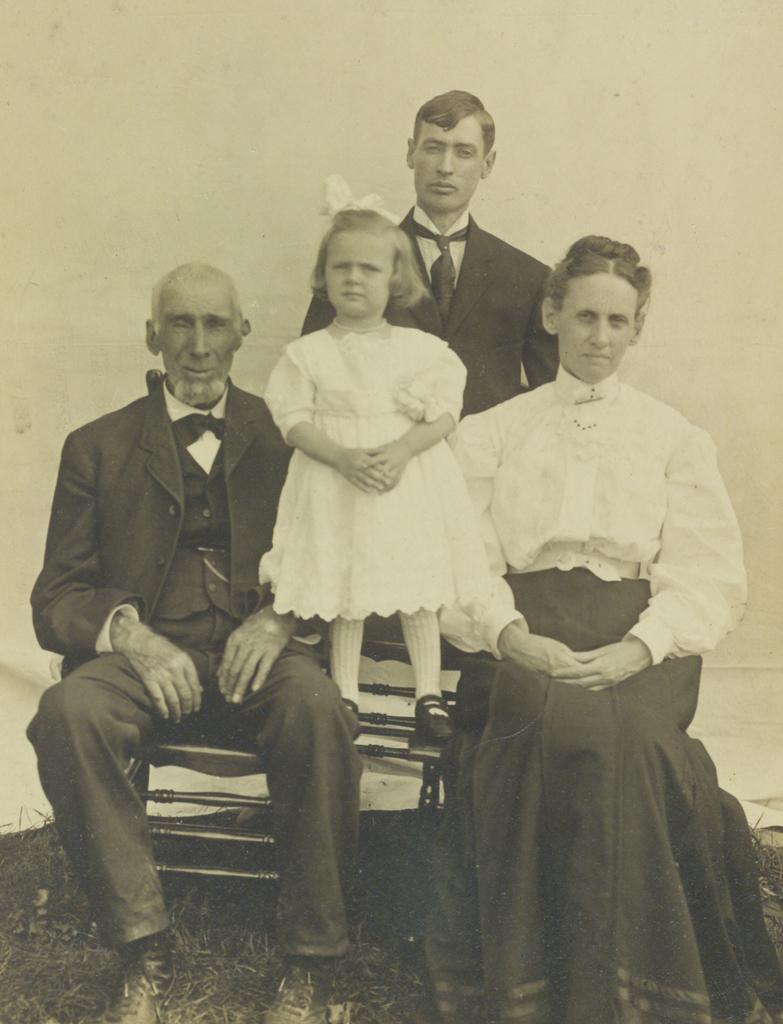In one or two sentences, can you explain what this image depicts? It is an old picture there a man and a woman are sitting on a bench and between them a baby is standing and behind these three people there is another man standing on the grass. 